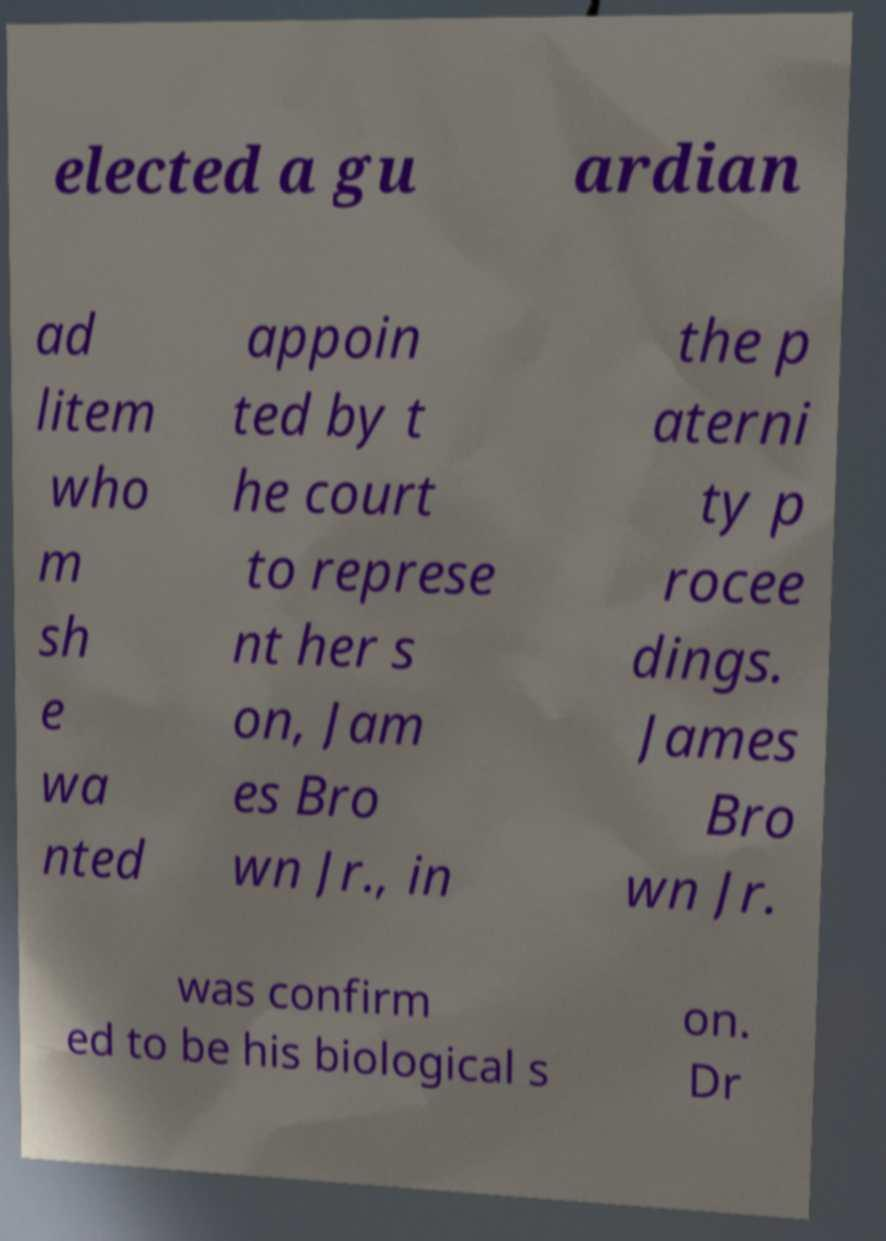Can you accurately transcribe the text from the provided image for me? elected a gu ardian ad litem who m sh e wa nted appoin ted by t he court to represe nt her s on, Jam es Bro wn Jr., in the p aterni ty p rocee dings. James Bro wn Jr. was confirm ed to be his biological s on. Dr 